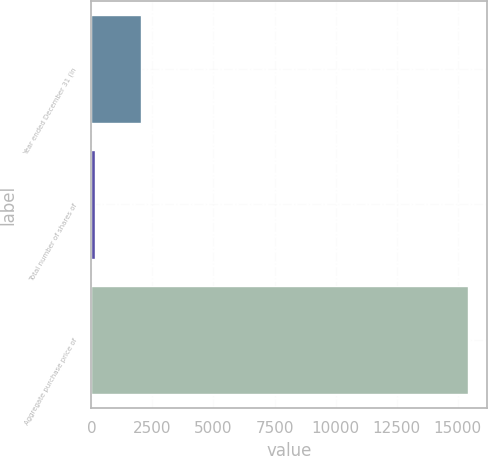Convert chart to OTSL. <chart><loc_0><loc_0><loc_500><loc_500><bar_chart><fcel>Year ended December 31 (in<fcel>Total number of shares of<fcel>Aggregate purchase price of<nl><fcel>2017<fcel>166.6<fcel>15410<nl></chart> 